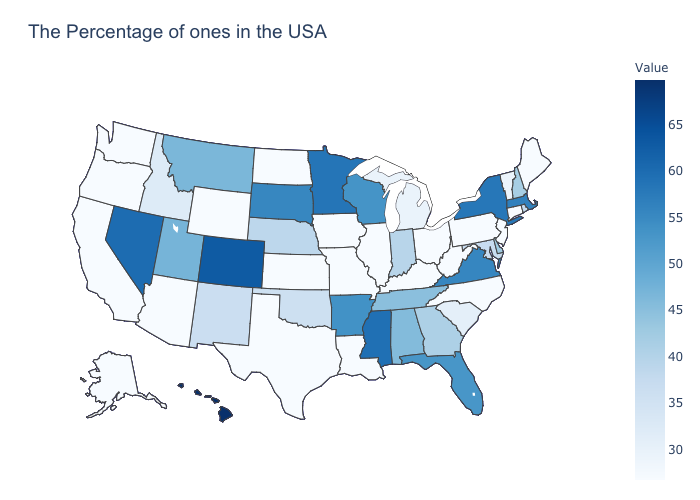Among the states that border New York , does Massachusetts have the lowest value?
Write a very short answer. No. Does the map have missing data?
Short answer required. No. Is the legend a continuous bar?
Keep it brief. Yes. Is the legend a continuous bar?
Quick response, please. Yes. Does New Mexico have the highest value in the West?
Quick response, please. No. Which states have the lowest value in the MidWest?
Give a very brief answer. Ohio, Illinois, Missouri, Iowa, Kansas, North Dakota. Which states hav the highest value in the MidWest?
Short answer required. Minnesota. 